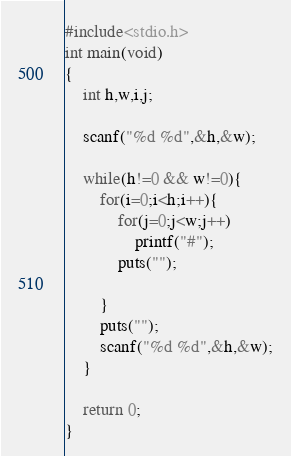Convert code to text. <code><loc_0><loc_0><loc_500><loc_500><_C_>#include<stdio.h>
int main(void)
{
	int h,w,i,j;

	scanf("%d %d",&h,&w);

	while(h!=0 && w!=0){
		for(i=0;i<h;i++){
			for(j=0;j<w;j++)
				printf("#");
			puts("");
			
		}
		puts("");
		scanf("%d %d",&h,&w);
	}

	return 0;
}</code> 